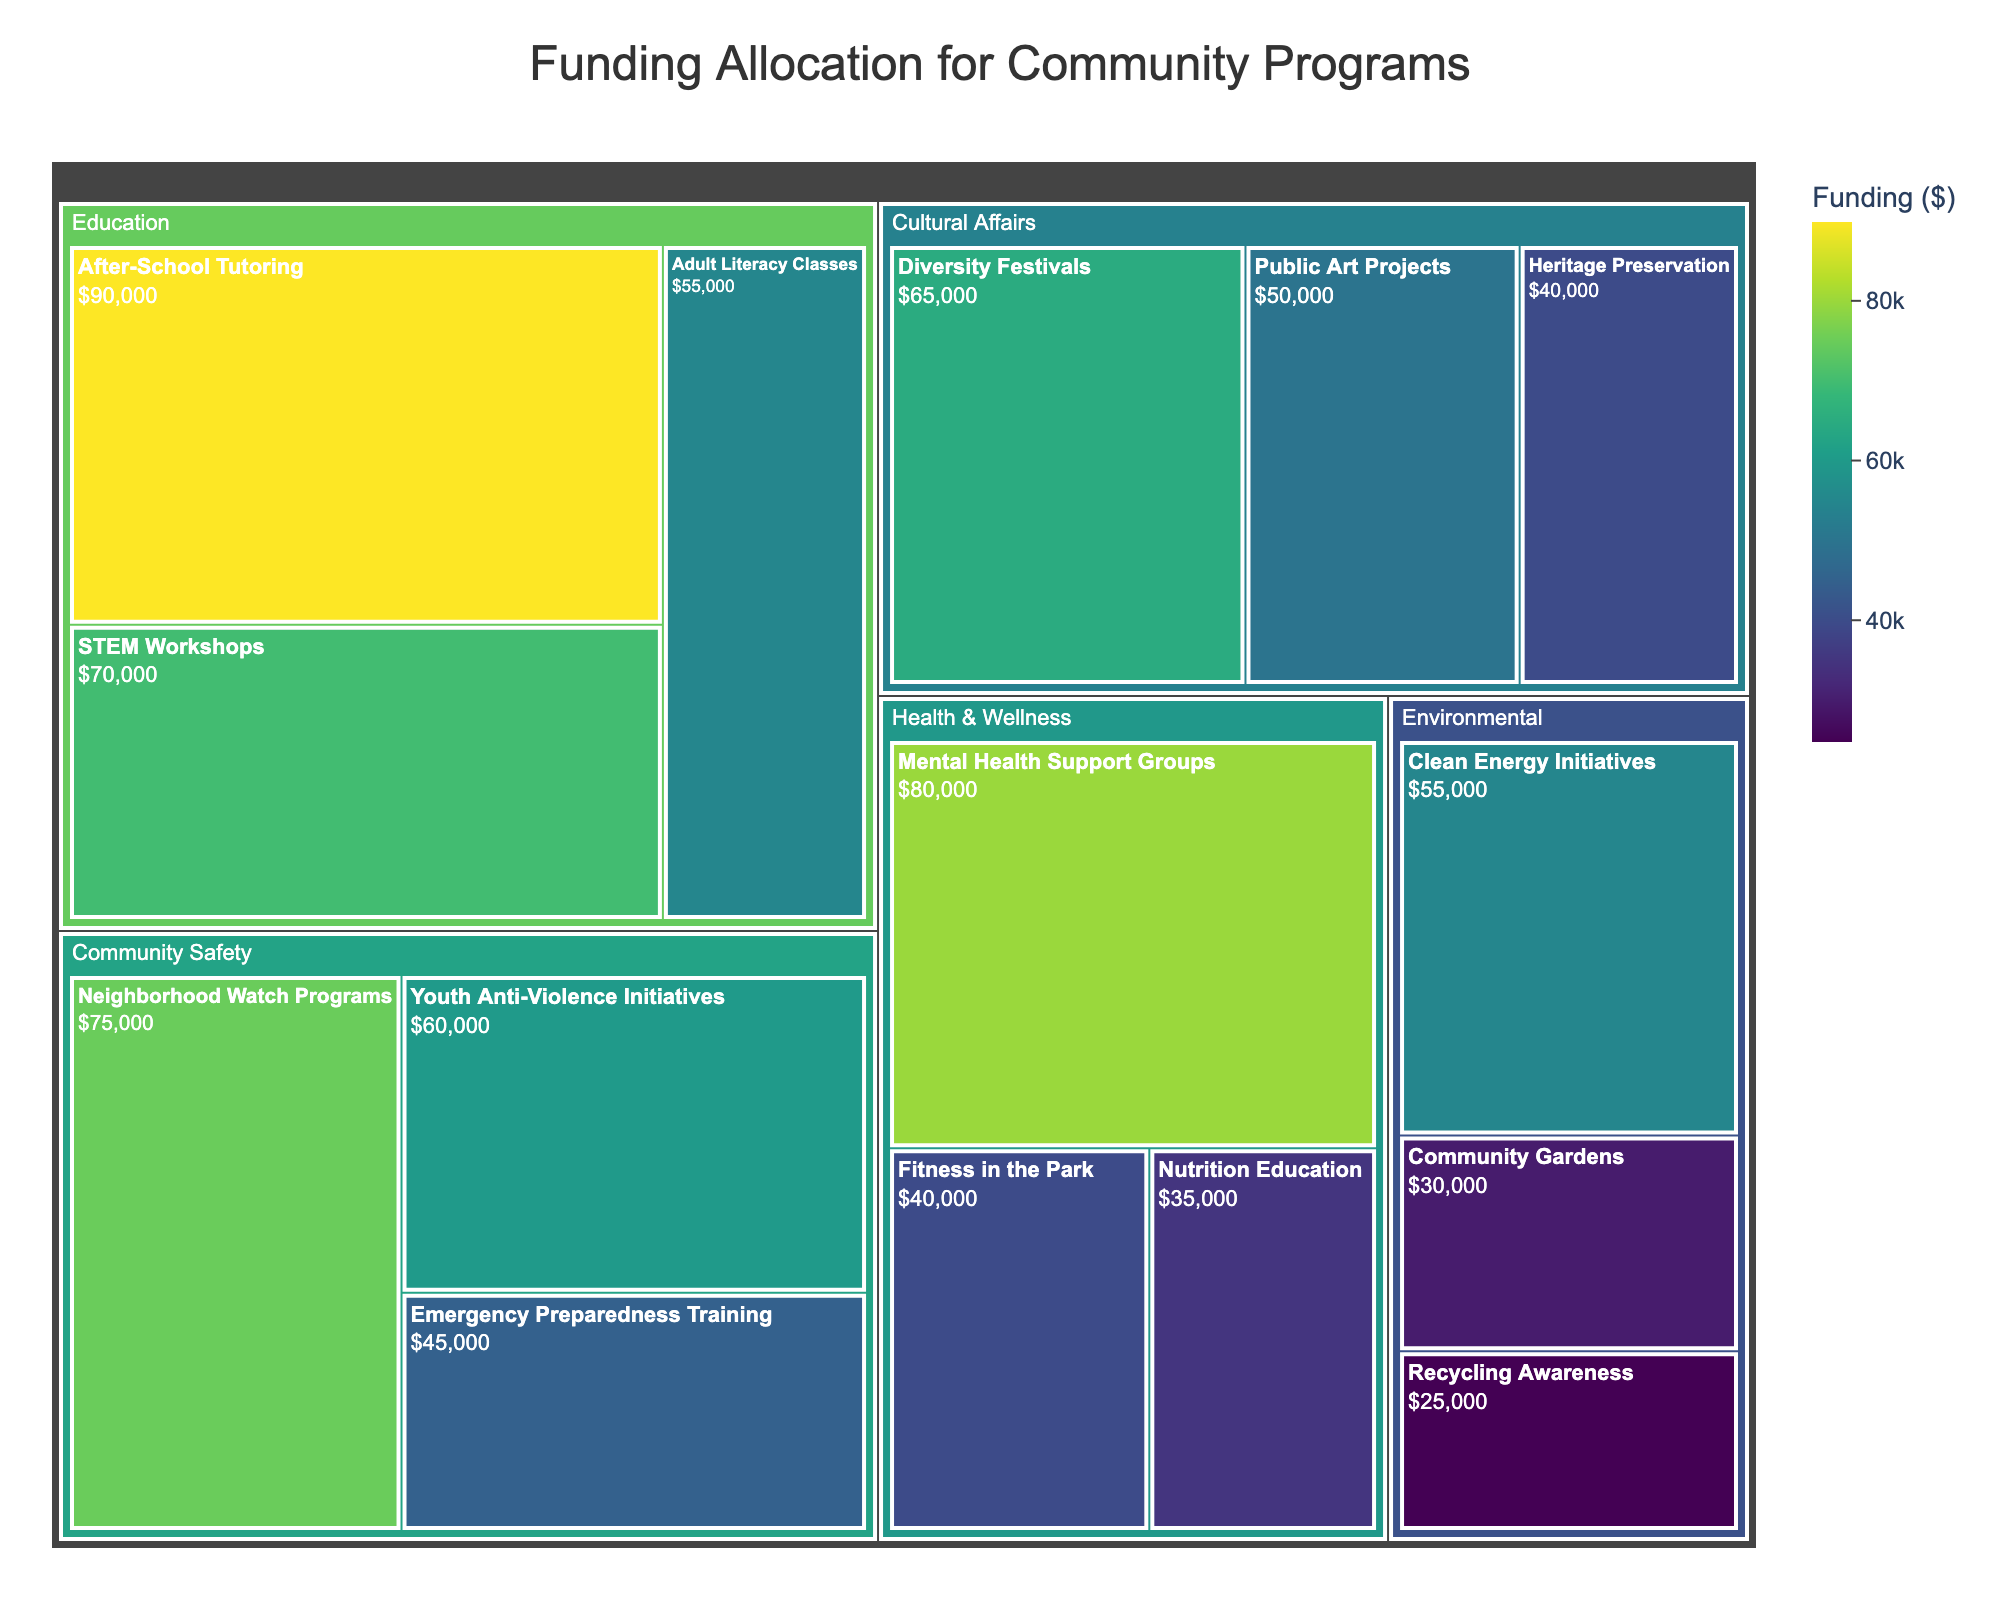What's the total funding allocated for Education programs? To find the total funding for Education programs, sum the funding allocations for After-School Tutoring, Adult Literacy Classes, and STEM Workshops. The total is $90,000 + $55,000 + $70,000.
Answer: $215,000 Which Subcategory within Health & Wellness received the highest funding? Compare the funding amounts of the three subcategories within Health & Wellness (Mental Health Support Groups, Fitness in the Park, and Nutrition Education). Mental Health Support Groups received the highest funding at $80,000.
Answer: Mental Health Support Groups How much more funding does Community Safety have compared to Environmental initiatives? Calculate the total funding for Community Safety and Environmental initiatives respectively, then find the difference. Community Safety (Neighborhood Watch Programs, Youth Anti-Violence Initiatives, Emergency Preparedness Training) has $75,000 + $60,000 + $45,000 = $180,000, and Environmental (Community Gardens, Recycling Awareness, Clean Energy Initiatives) has $30,000 + $25,000 + $55,000 = $110,000. The difference is $180,000 - $110,000.
Answer: $70,000 What is the average funding per subcategory within Cultural Affairs? Sum the funding for all subcategories in Cultural Affairs and divide by the number of subcategories. The total is $65,000 + $50,000 + $40,000 = $155,000. There are 3 subcategories, so the average is $155,000 / 3.
Answer: $51,666.67 Which category received the overall highest funding? Sum the funding for all subcategories within each category and compare the totals. Education has $215,000, Community Safety $180,000, Health & Wellness $155,000, Cultural Affairs $155,000, and Environmental $110,000. Education received the highest total funding.
Answer: Education Is the funding for After-School Tutoring greater than the combined funding for Community Gardens and Recycling Awareness? Compare the funding for After-School Tutoring ($90,000) against the sum of Community Gardens and Recycling Awareness ($30,000 + $25,000 = $55,000). $90,000 is greater than $55,000.
Answer: Yes What is the funding difference between the highest and lowest funded subcategories overall? Identify the highest ($90,000 for After-School Tutoring) and lowest ($25,000 for Recycling Awareness) funded subcategories, then find the difference. $90,000 - $25,000.
Answer: $65,000 How many subcategories received funding of $50,000 or more? Examine each subcategory's funding and count how many are $50,000 or more. The qualifying subcategories are Neighborhood Watch Programs, Youth Anti-Violence Initiatives, After-School Tutoring, Adult Literacy Classes, STEM Workshops, Mental Health Support Groups, Diversity Festivals, Public Art Projects, and Clean Energy Initiatives.
Answer: 9 